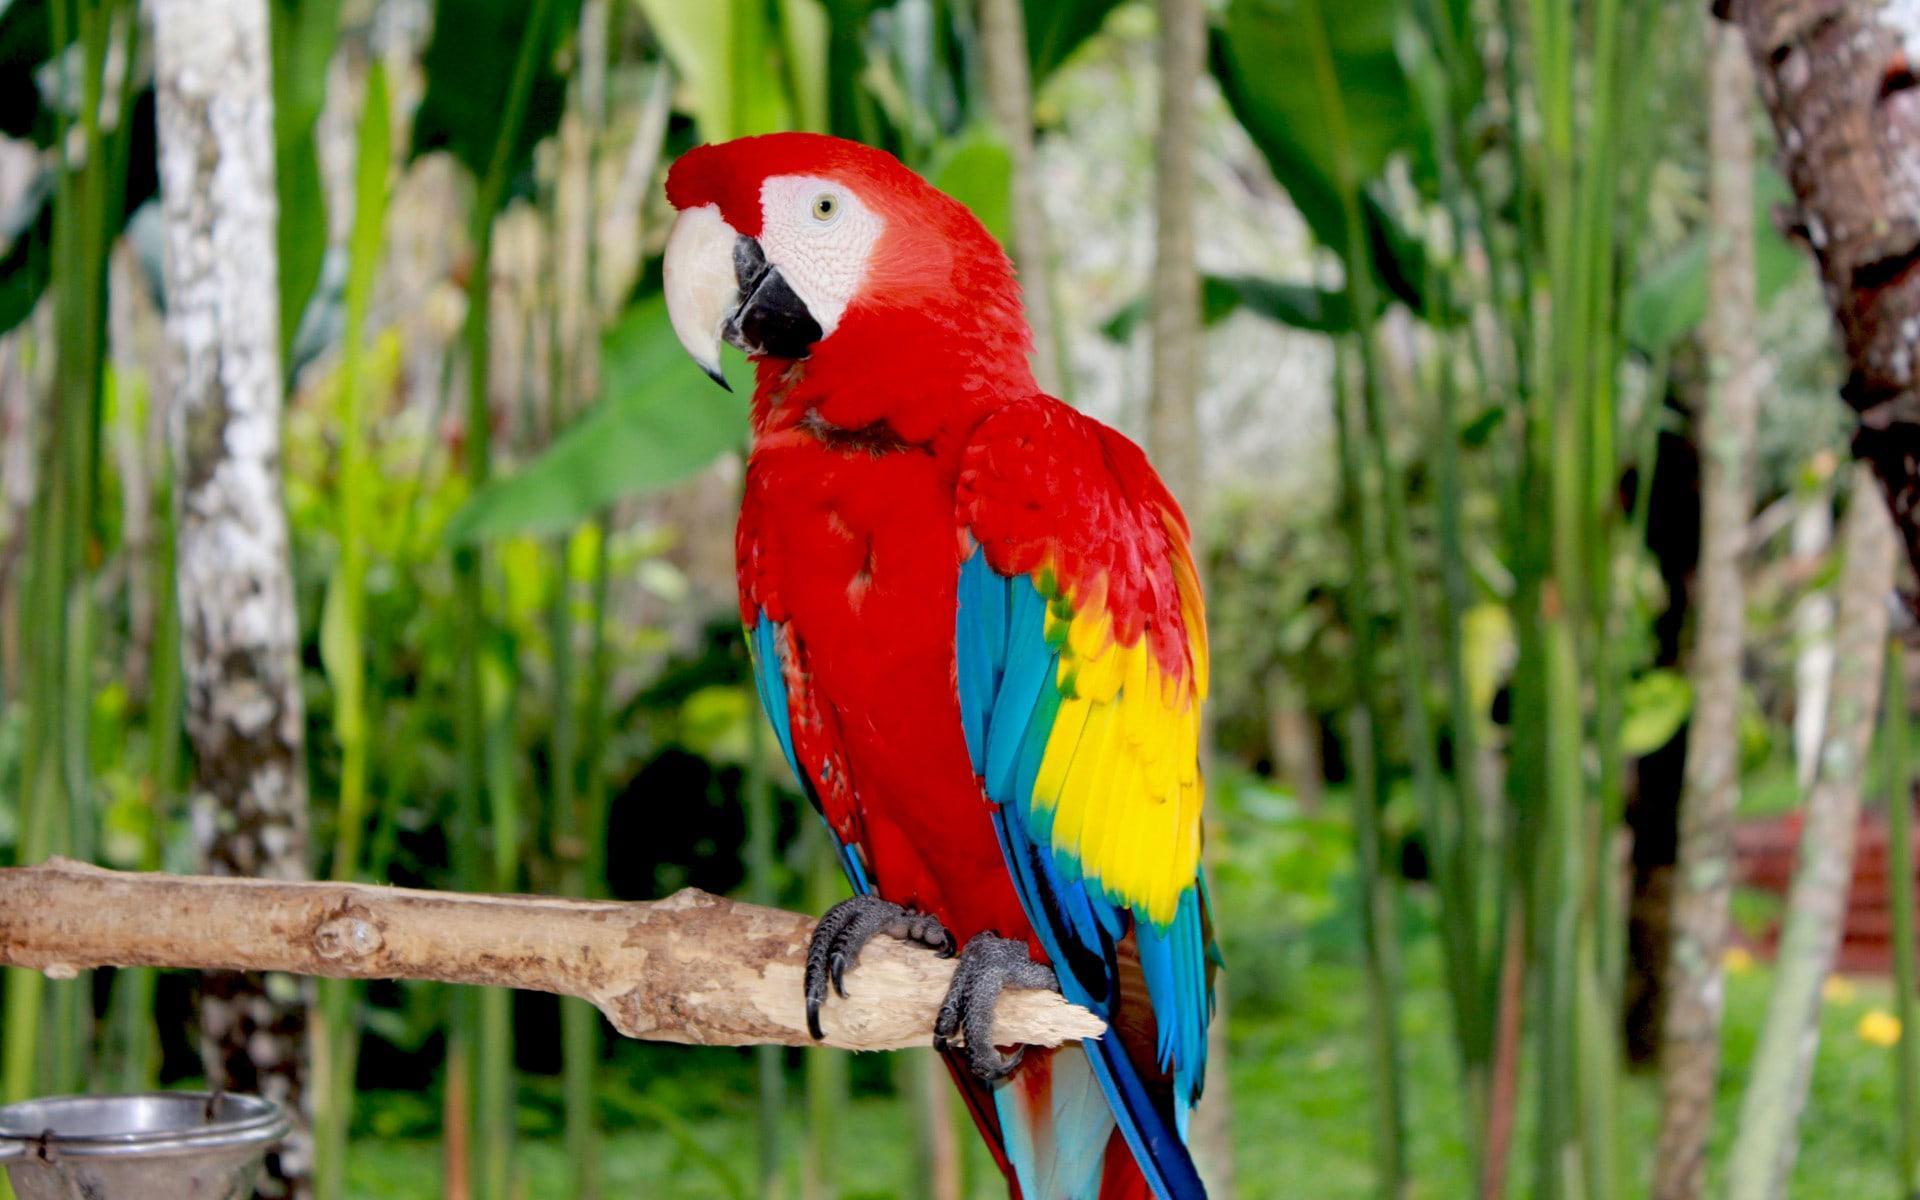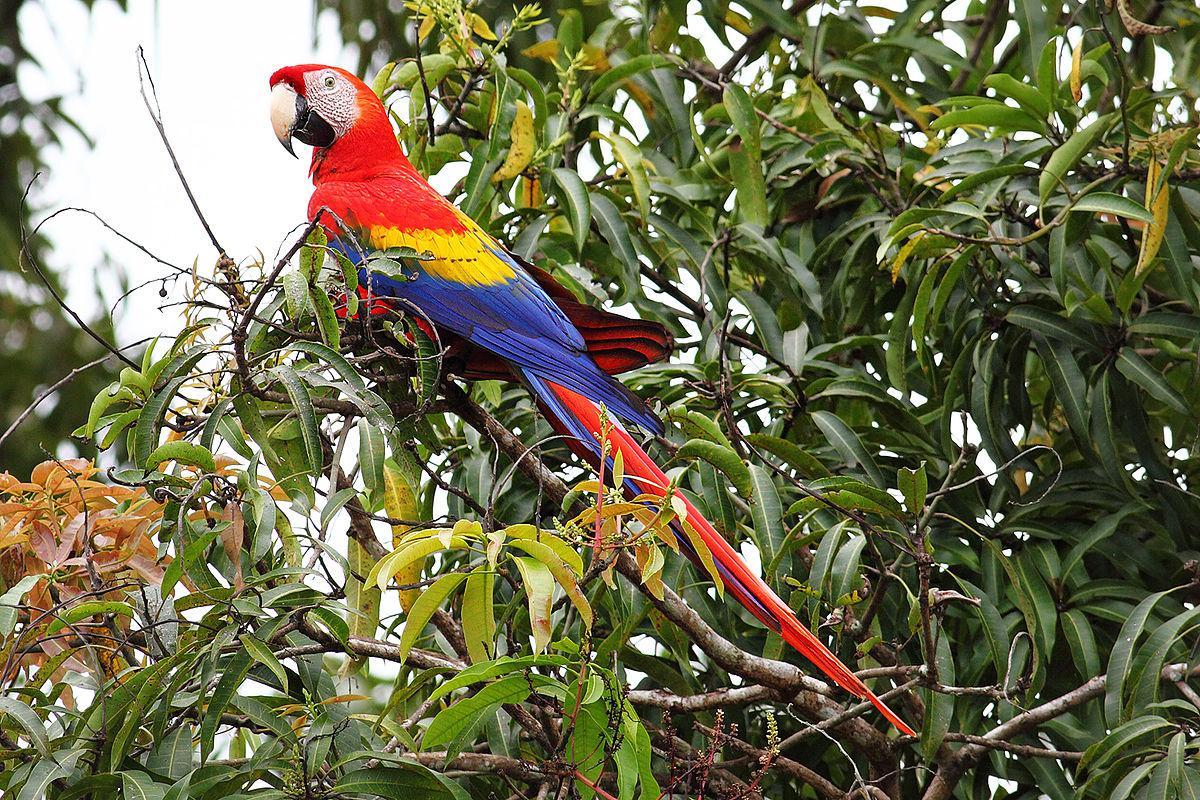The first image is the image on the left, the second image is the image on the right. For the images displayed, is the sentence "There are three parrots" factually correct? Answer yes or no. No. The first image is the image on the left, the second image is the image on the right. Given the left and right images, does the statement "Three parrots have red feathered heads and white beaks." hold true? Answer yes or no. No. 